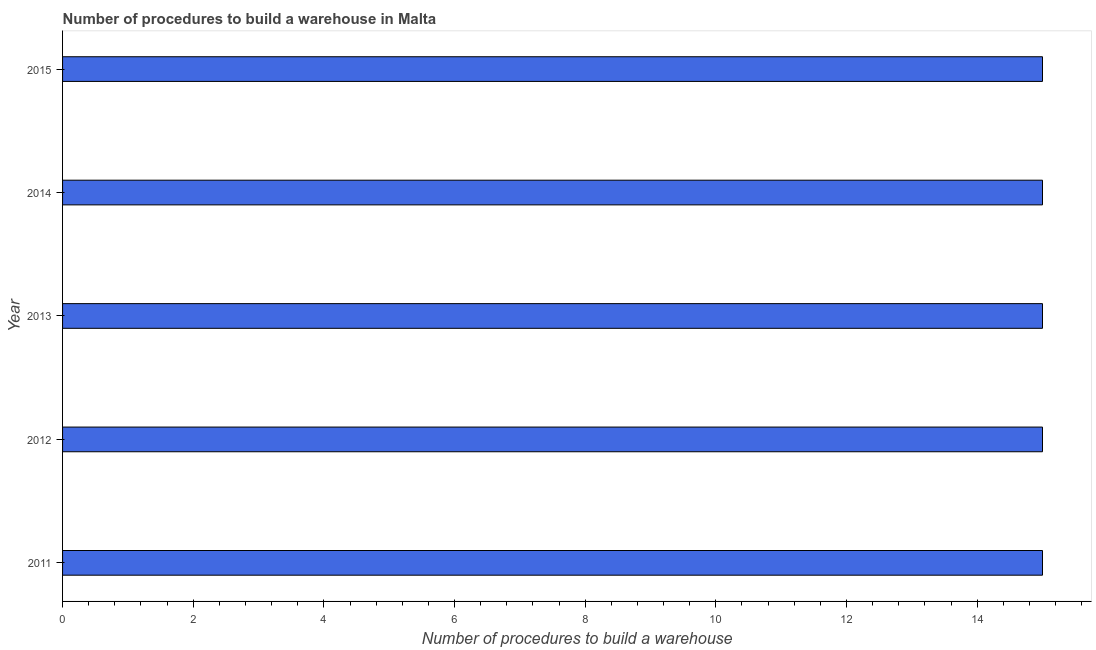Does the graph contain grids?
Your answer should be very brief. No. What is the title of the graph?
Ensure brevity in your answer.  Number of procedures to build a warehouse in Malta. What is the label or title of the X-axis?
Your answer should be very brief. Number of procedures to build a warehouse. What is the number of procedures to build a warehouse in 2012?
Ensure brevity in your answer.  15. In which year was the number of procedures to build a warehouse maximum?
Ensure brevity in your answer.  2011. In which year was the number of procedures to build a warehouse minimum?
Your response must be concise. 2011. What is the difference between the highest and the second highest number of procedures to build a warehouse?
Provide a short and direct response. 0. What is the difference between the highest and the lowest number of procedures to build a warehouse?
Ensure brevity in your answer.  0. Are all the bars in the graph horizontal?
Offer a very short reply. Yes. What is the difference between two consecutive major ticks on the X-axis?
Your response must be concise. 2. Are the values on the major ticks of X-axis written in scientific E-notation?
Ensure brevity in your answer.  No. What is the Number of procedures to build a warehouse of 2011?
Keep it short and to the point. 15. What is the Number of procedures to build a warehouse in 2012?
Provide a short and direct response. 15. What is the Number of procedures to build a warehouse in 2014?
Offer a very short reply. 15. What is the Number of procedures to build a warehouse in 2015?
Provide a short and direct response. 15. What is the difference between the Number of procedures to build a warehouse in 2011 and 2012?
Provide a short and direct response. 0. What is the difference between the Number of procedures to build a warehouse in 2011 and 2013?
Provide a short and direct response. 0. What is the difference between the Number of procedures to build a warehouse in 2011 and 2014?
Give a very brief answer. 0. What is the difference between the Number of procedures to build a warehouse in 2012 and 2013?
Your answer should be compact. 0. What is the difference between the Number of procedures to build a warehouse in 2013 and 2014?
Your answer should be compact. 0. What is the ratio of the Number of procedures to build a warehouse in 2011 to that in 2014?
Ensure brevity in your answer.  1. What is the ratio of the Number of procedures to build a warehouse in 2011 to that in 2015?
Offer a terse response. 1. What is the ratio of the Number of procedures to build a warehouse in 2013 to that in 2014?
Give a very brief answer. 1. What is the ratio of the Number of procedures to build a warehouse in 2013 to that in 2015?
Provide a short and direct response. 1. 